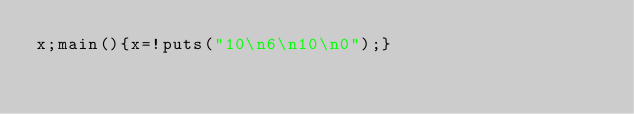<code> <loc_0><loc_0><loc_500><loc_500><_C_>x;main(){x=!puts("10\n6\n10\n0");}</code> 